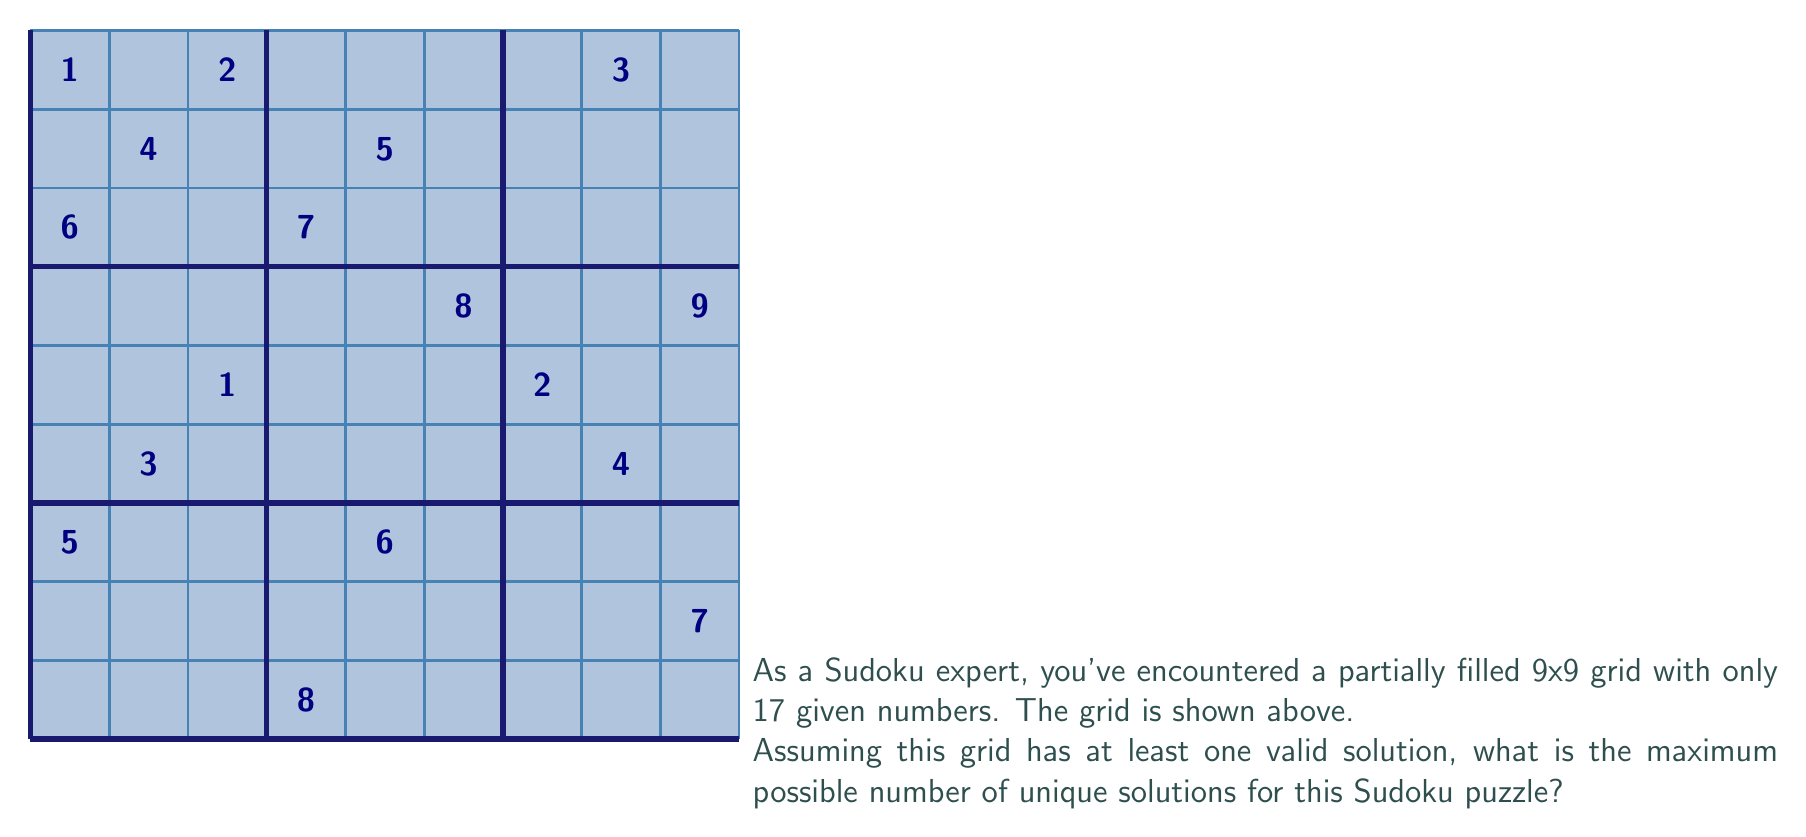Solve this math problem. To solve this problem, we need to consider the following steps:

1) First, recall that a standard 9x9 Sudoku grid has $9^2 = 81$ cells.

2) In this partially filled grid, we have 17 given numbers. Therefore, there are $81 - 17 = 64$ empty cells to be filled.

3) Each empty cell can potentially be filled with any number from 1 to 9. However, due to Sudoku rules (each number must appear exactly once in each row, column, and 3x3 sub-grid), the actual number of possibilities for each cell is typically much less than 9.

4) In the worst-case scenario (which would give us the maximum number of solutions), each empty cell would have 2 possible values that satisfy all Sudoku rules.

5) If each of the 64 empty cells had 2 possible values, the total number of possible combinations would be $2^{64}$.

6) However, this is an overestimate because many of these combinations would violate Sudoku rules when considered as a whole grid.

7) The actual maximum number of valid solutions for a Sudoku puzzle with 17 given numbers has been proven to be much smaller. Through extensive computer analysis, it has been shown that the maximum number of solutions for a Sudoku puzzle with 17 clues is 2.

8) This result was proven by exhaustive computer search in 2012 by McGuire, Tugemann, and Civario.

Therefore, the maximum possible number of unique solutions for this Sudoku puzzle is 2.
Answer: 2 